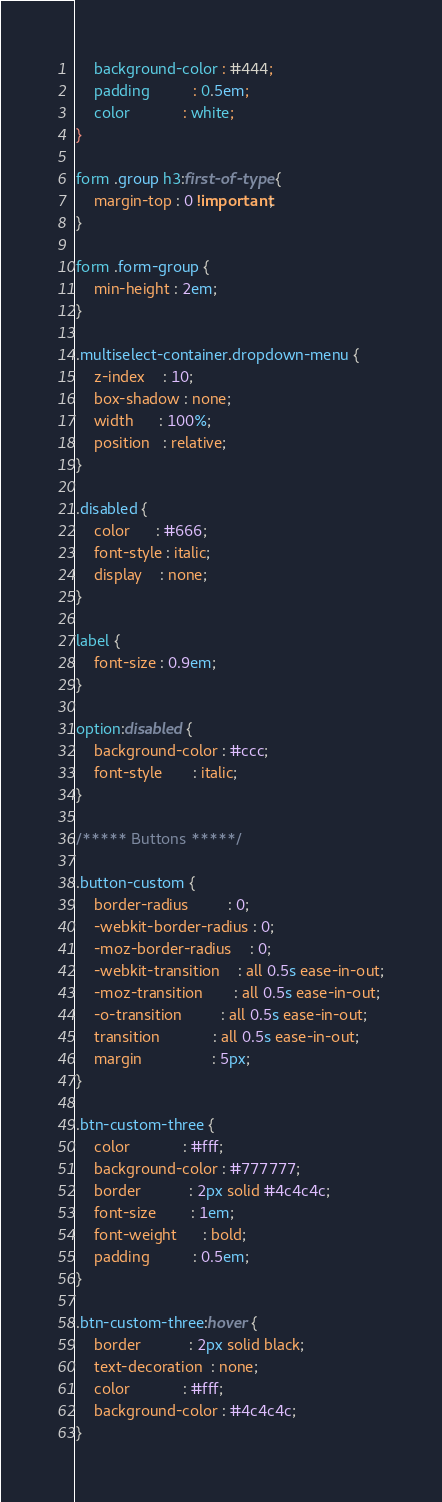<code> <loc_0><loc_0><loc_500><loc_500><_CSS_>    background-color : #444;
    padding          : 0.5em;
    color            : white;
}

form .group h3:first-of-type {
    margin-top : 0 !important;
}

form .form-group {
    min-height : 2em;
}

.multiselect-container.dropdown-menu {
    z-index    : 10;
    box-shadow : none;
    width      : 100%;
    position   : relative;
}

.disabled {
    color      : #666;
    font-style : italic;
    display    : none;
}

label {
    font-size : 0.9em;
}

option:disabled {
    background-color : #ccc;
    font-style       : italic;
}

/***** Buttons *****/

.button-custom {
    border-radius         : 0;
    -webkit-border-radius : 0;
    -moz-border-radius    : 0;
    -webkit-transition    : all 0.5s ease-in-out;
    -moz-transition       : all 0.5s ease-in-out;
    -o-transition         : all 0.5s ease-in-out;
    transition            : all 0.5s ease-in-out;
    margin                : 5px;
}

.btn-custom-three {
    color            : #fff;
    background-color : #777777;
    border           : 2px solid #4c4c4c;
    font-size        : 1em;
    font-weight      : bold;
    padding          : 0.5em;
}

.btn-custom-three:hover {
    border           : 2px solid black;
    text-decoration  : none;
    color            : #fff;
    background-color : #4c4c4c;
}
</code> 